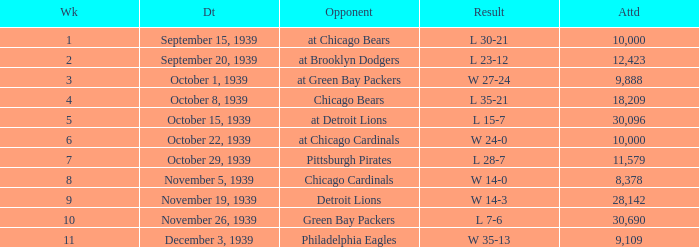Which Attendance has an Opponent of green bay packers, and a Week larger than 10? None. 